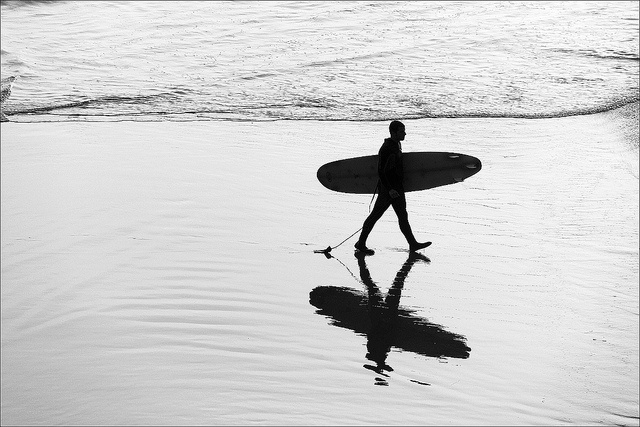Describe the objects in this image and their specific colors. I can see surfboard in black, white, gray, and darkgray tones and people in black, white, gray, and darkgray tones in this image. 